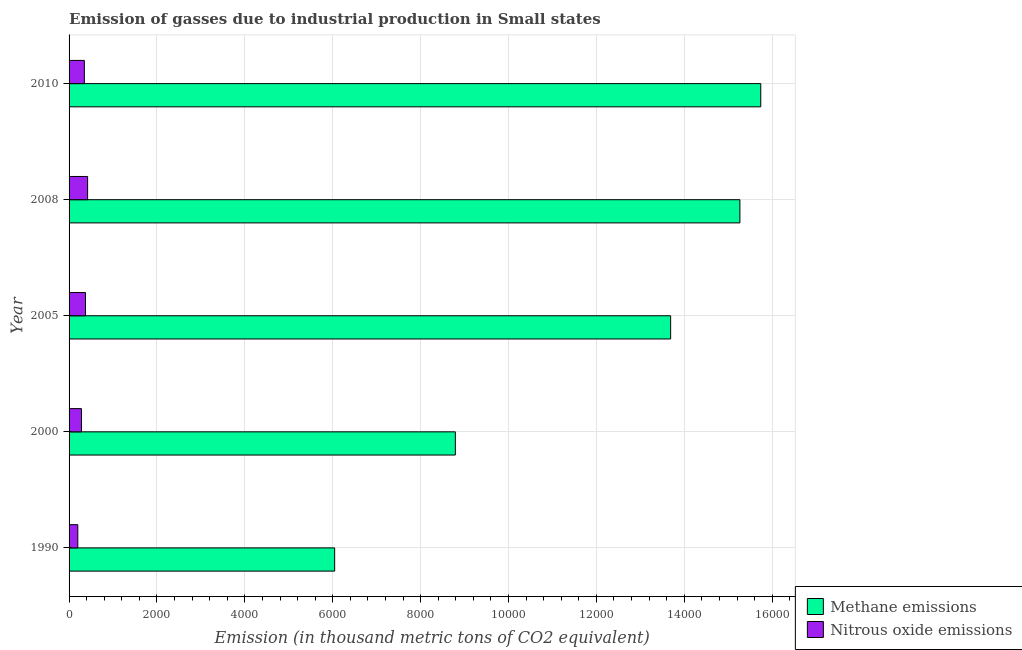How many different coloured bars are there?
Give a very brief answer. 2. Are the number of bars per tick equal to the number of legend labels?
Give a very brief answer. Yes. How many bars are there on the 3rd tick from the top?
Keep it short and to the point. 2. What is the label of the 1st group of bars from the top?
Your response must be concise. 2010. In how many cases, is the number of bars for a given year not equal to the number of legend labels?
Ensure brevity in your answer.  0. What is the amount of methane emissions in 1990?
Your response must be concise. 6043.6. Across all years, what is the maximum amount of nitrous oxide emissions?
Give a very brief answer. 421.7. Across all years, what is the minimum amount of methane emissions?
Give a very brief answer. 6043.6. What is the total amount of methane emissions in the graph?
Ensure brevity in your answer.  5.95e+04. What is the difference between the amount of nitrous oxide emissions in 1990 and that in 2005?
Provide a short and direct response. -175.5. What is the difference between the amount of nitrous oxide emissions in 2008 and the amount of methane emissions in 1990?
Ensure brevity in your answer.  -5621.9. What is the average amount of nitrous oxide emissions per year?
Provide a succinct answer. 324.94. In the year 2005, what is the difference between the amount of methane emissions and amount of nitrous oxide emissions?
Your response must be concise. 1.33e+04. What is the ratio of the amount of nitrous oxide emissions in 2005 to that in 2008?
Your response must be concise. 0.89. Is the amount of methane emissions in 2000 less than that in 2010?
Ensure brevity in your answer.  Yes. Is the difference between the amount of methane emissions in 1990 and 2010 greater than the difference between the amount of nitrous oxide emissions in 1990 and 2010?
Keep it short and to the point. No. What is the difference between the highest and the second highest amount of methane emissions?
Keep it short and to the point. 474.8. What is the difference between the highest and the lowest amount of methane emissions?
Make the answer very short. 9696.7. In how many years, is the amount of methane emissions greater than the average amount of methane emissions taken over all years?
Provide a short and direct response. 3. What does the 2nd bar from the top in 2000 represents?
Ensure brevity in your answer.  Methane emissions. What does the 2nd bar from the bottom in 2005 represents?
Give a very brief answer. Nitrous oxide emissions. How many years are there in the graph?
Make the answer very short. 5. Does the graph contain any zero values?
Your response must be concise. No. Where does the legend appear in the graph?
Provide a succinct answer. Bottom right. How many legend labels are there?
Offer a very short reply. 2. How are the legend labels stacked?
Your response must be concise. Vertical. What is the title of the graph?
Your response must be concise. Emission of gasses due to industrial production in Small states. Does "Private creditors" appear as one of the legend labels in the graph?
Give a very brief answer. No. What is the label or title of the X-axis?
Your answer should be very brief. Emission (in thousand metric tons of CO2 equivalent). What is the Emission (in thousand metric tons of CO2 equivalent) of Methane emissions in 1990?
Give a very brief answer. 6043.6. What is the Emission (in thousand metric tons of CO2 equivalent) in Nitrous oxide emissions in 1990?
Your response must be concise. 198.5. What is the Emission (in thousand metric tons of CO2 equivalent) in Methane emissions in 2000?
Give a very brief answer. 8790. What is the Emission (in thousand metric tons of CO2 equivalent) in Nitrous oxide emissions in 2000?
Provide a short and direct response. 282.6. What is the Emission (in thousand metric tons of CO2 equivalent) of Methane emissions in 2005?
Offer a terse response. 1.37e+04. What is the Emission (in thousand metric tons of CO2 equivalent) of Nitrous oxide emissions in 2005?
Your answer should be compact. 374. What is the Emission (in thousand metric tons of CO2 equivalent) in Methane emissions in 2008?
Your response must be concise. 1.53e+04. What is the Emission (in thousand metric tons of CO2 equivalent) of Nitrous oxide emissions in 2008?
Ensure brevity in your answer.  421.7. What is the Emission (in thousand metric tons of CO2 equivalent) of Methane emissions in 2010?
Give a very brief answer. 1.57e+04. What is the Emission (in thousand metric tons of CO2 equivalent) in Nitrous oxide emissions in 2010?
Keep it short and to the point. 347.9. Across all years, what is the maximum Emission (in thousand metric tons of CO2 equivalent) of Methane emissions?
Ensure brevity in your answer.  1.57e+04. Across all years, what is the maximum Emission (in thousand metric tons of CO2 equivalent) of Nitrous oxide emissions?
Offer a very short reply. 421.7. Across all years, what is the minimum Emission (in thousand metric tons of CO2 equivalent) in Methane emissions?
Ensure brevity in your answer.  6043.6. Across all years, what is the minimum Emission (in thousand metric tons of CO2 equivalent) in Nitrous oxide emissions?
Provide a short and direct response. 198.5. What is the total Emission (in thousand metric tons of CO2 equivalent) in Methane emissions in the graph?
Make the answer very short. 5.95e+04. What is the total Emission (in thousand metric tons of CO2 equivalent) in Nitrous oxide emissions in the graph?
Keep it short and to the point. 1624.7. What is the difference between the Emission (in thousand metric tons of CO2 equivalent) in Methane emissions in 1990 and that in 2000?
Ensure brevity in your answer.  -2746.4. What is the difference between the Emission (in thousand metric tons of CO2 equivalent) in Nitrous oxide emissions in 1990 and that in 2000?
Your answer should be very brief. -84.1. What is the difference between the Emission (in thousand metric tons of CO2 equivalent) of Methane emissions in 1990 and that in 2005?
Offer a very short reply. -7645.8. What is the difference between the Emission (in thousand metric tons of CO2 equivalent) in Nitrous oxide emissions in 1990 and that in 2005?
Provide a short and direct response. -175.5. What is the difference between the Emission (in thousand metric tons of CO2 equivalent) of Methane emissions in 1990 and that in 2008?
Your answer should be compact. -9221.9. What is the difference between the Emission (in thousand metric tons of CO2 equivalent) in Nitrous oxide emissions in 1990 and that in 2008?
Your response must be concise. -223.2. What is the difference between the Emission (in thousand metric tons of CO2 equivalent) in Methane emissions in 1990 and that in 2010?
Make the answer very short. -9696.7. What is the difference between the Emission (in thousand metric tons of CO2 equivalent) in Nitrous oxide emissions in 1990 and that in 2010?
Provide a succinct answer. -149.4. What is the difference between the Emission (in thousand metric tons of CO2 equivalent) of Methane emissions in 2000 and that in 2005?
Keep it short and to the point. -4899.4. What is the difference between the Emission (in thousand metric tons of CO2 equivalent) of Nitrous oxide emissions in 2000 and that in 2005?
Your response must be concise. -91.4. What is the difference between the Emission (in thousand metric tons of CO2 equivalent) in Methane emissions in 2000 and that in 2008?
Your response must be concise. -6475.5. What is the difference between the Emission (in thousand metric tons of CO2 equivalent) in Nitrous oxide emissions in 2000 and that in 2008?
Keep it short and to the point. -139.1. What is the difference between the Emission (in thousand metric tons of CO2 equivalent) of Methane emissions in 2000 and that in 2010?
Make the answer very short. -6950.3. What is the difference between the Emission (in thousand metric tons of CO2 equivalent) of Nitrous oxide emissions in 2000 and that in 2010?
Your answer should be compact. -65.3. What is the difference between the Emission (in thousand metric tons of CO2 equivalent) in Methane emissions in 2005 and that in 2008?
Keep it short and to the point. -1576.1. What is the difference between the Emission (in thousand metric tons of CO2 equivalent) in Nitrous oxide emissions in 2005 and that in 2008?
Keep it short and to the point. -47.7. What is the difference between the Emission (in thousand metric tons of CO2 equivalent) of Methane emissions in 2005 and that in 2010?
Offer a very short reply. -2050.9. What is the difference between the Emission (in thousand metric tons of CO2 equivalent) in Nitrous oxide emissions in 2005 and that in 2010?
Offer a very short reply. 26.1. What is the difference between the Emission (in thousand metric tons of CO2 equivalent) of Methane emissions in 2008 and that in 2010?
Give a very brief answer. -474.8. What is the difference between the Emission (in thousand metric tons of CO2 equivalent) of Nitrous oxide emissions in 2008 and that in 2010?
Make the answer very short. 73.8. What is the difference between the Emission (in thousand metric tons of CO2 equivalent) in Methane emissions in 1990 and the Emission (in thousand metric tons of CO2 equivalent) in Nitrous oxide emissions in 2000?
Offer a terse response. 5761. What is the difference between the Emission (in thousand metric tons of CO2 equivalent) in Methane emissions in 1990 and the Emission (in thousand metric tons of CO2 equivalent) in Nitrous oxide emissions in 2005?
Keep it short and to the point. 5669.6. What is the difference between the Emission (in thousand metric tons of CO2 equivalent) of Methane emissions in 1990 and the Emission (in thousand metric tons of CO2 equivalent) of Nitrous oxide emissions in 2008?
Your answer should be very brief. 5621.9. What is the difference between the Emission (in thousand metric tons of CO2 equivalent) of Methane emissions in 1990 and the Emission (in thousand metric tons of CO2 equivalent) of Nitrous oxide emissions in 2010?
Provide a succinct answer. 5695.7. What is the difference between the Emission (in thousand metric tons of CO2 equivalent) in Methane emissions in 2000 and the Emission (in thousand metric tons of CO2 equivalent) in Nitrous oxide emissions in 2005?
Keep it short and to the point. 8416. What is the difference between the Emission (in thousand metric tons of CO2 equivalent) in Methane emissions in 2000 and the Emission (in thousand metric tons of CO2 equivalent) in Nitrous oxide emissions in 2008?
Your answer should be compact. 8368.3. What is the difference between the Emission (in thousand metric tons of CO2 equivalent) of Methane emissions in 2000 and the Emission (in thousand metric tons of CO2 equivalent) of Nitrous oxide emissions in 2010?
Give a very brief answer. 8442.1. What is the difference between the Emission (in thousand metric tons of CO2 equivalent) in Methane emissions in 2005 and the Emission (in thousand metric tons of CO2 equivalent) in Nitrous oxide emissions in 2008?
Your response must be concise. 1.33e+04. What is the difference between the Emission (in thousand metric tons of CO2 equivalent) in Methane emissions in 2005 and the Emission (in thousand metric tons of CO2 equivalent) in Nitrous oxide emissions in 2010?
Give a very brief answer. 1.33e+04. What is the difference between the Emission (in thousand metric tons of CO2 equivalent) in Methane emissions in 2008 and the Emission (in thousand metric tons of CO2 equivalent) in Nitrous oxide emissions in 2010?
Keep it short and to the point. 1.49e+04. What is the average Emission (in thousand metric tons of CO2 equivalent) of Methane emissions per year?
Your answer should be compact. 1.19e+04. What is the average Emission (in thousand metric tons of CO2 equivalent) in Nitrous oxide emissions per year?
Your response must be concise. 324.94. In the year 1990, what is the difference between the Emission (in thousand metric tons of CO2 equivalent) in Methane emissions and Emission (in thousand metric tons of CO2 equivalent) in Nitrous oxide emissions?
Ensure brevity in your answer.  5845.1. In the year 2000, what is the difference between the Emission (in thousand metric tons of CO2 equivalent) of Methane emissions and Emission (in thousand metric tons of CO2 equivalent) of Nitrous oxide emissions?
Provide a short and direct response. 8507.4. In the year 2005, what is the difference between the Emission (in thousand metric tons of CO2 equivalent) of Methane emissions and Emission (in thousand metric tons of CO2 equivalent) of Nitrous oxide emissions?
Offer a terse response. 1.33e+04. In the year 2008, what is the difference between the Emission (in thousand metric tons of CO2 equivalent) of Methane emissions and Emission (in thousand metric tons of CO2 equivalent) of Nitrous oxide emissions?
Your response must be concise. 1.48e+04. In the year 2010, what is the difference between the Emission (in thousand metric tons of CO2 equivalent) of Methane emissions and Emission (in thousand metric tons of CO2 equivalent) of Nitrous oxide emissions?
Provide a short and direct response. 1.54e+04. What is the ratio of the Emission (in thousand metric tons of CO2 equivalent) of Methane emissions in 1990 to that in 2000?
Provide a short and direct response. 0.69. What is the ratio of the Emission (in thousand metric tons of CO2 equivalent) in Nitrous oxide emissions in 1990 to that in 2000?
Your answer should be compact. 0.7. What is the ratio of the Emission (in thousand metric tons of CO2 equivalent) in Methane emissions in 1990 to that in 2005?
Your response must be concise. 0.44. What is the ratio of the Emission (in thousand metric tons of CO2 equivalent) in Nitrous oxide emissions in 1990 to that in 2005?
Give a very brief answer. 0.53. What is the ratio of the Emission (in thousand metric tons of CO2 equivalent) of Methane emissions in 1990 to that in 2008?
Provide a short and direct response. 0.4. What is the ratio of the Emission (in thousand metric tons of CO2 equivalent) of Nitrous oxide emissions in 1990 to that in 2008?
Provide a short and direct response. 0.47. What is the ratio of the Emission (in thousand metric tons of CO2 equivalent) in Methane emissions in 1990 to that in 2010?
Your answer should be compact. 0.38. What is the ratio of the Emission (in thousand metric tons of CO2 equivalent) of Nitrous oxide emissions in 1990 to that in 2010?
Make the answer very short. 0.57. What is the ratio of the Emission (in thousand metric tons of CO2 equivalent) of Methane emissions in 2000 to that in 2005?
Provide a succinct answer. 0.64. What is the ratio of the Emission (in thousand metric tons of CO2 equivalent) in Nitrous oxide emissions in 2000 to that in 2005?
Ensure brevity in your answer.  0.76. What is the ratio of the Emission (in thousand metric tons of CO2 equivalent) in Methane emissions in 2000 to that in 2008?
Your response must be concise. 0.58. What is the ratio of the Emission (in thousand metric tons of CO2 equivalent) in Nitrous oxide emissions in 2000 to that in 2008?
Provide a short and direct response. 0.67. What is the ratio of the Emission (in thousand metric tons of CO2 equivalent) in Methane emissions in 2000 to that in 2010?
Offer a terse response. 0.56. What is the ratio of the Emission (in thousand metric tons of CO2 equivalent) of Nitrous oxide emissions in 2000 to that in 2010?
Your answer should be very brief. 0.81. What is the ratio of the Emission (in thousand metric tons of CO2 equivalent) in Methane emissions in 2005 to that in 2008?
Your answer should be very brief. 0.9. What is the ratio of the Emission (in thousand metric tons of CO2 equivalent) in Nitrous oxide emissions in 2005 to that in 2008?
Offer a very short reply. 0.89. What is the ratio of the Emission (in thousand metric tons of CO2 equivalent) in Methane emissions in 2005 to that in 2010?
Ensure brevity in your answer.  0.87. What is the ratio of the Emission (in thousand metric tons of CO2 equivalent) in Nitrous oxide emissions in 2005 to that in 2010?
Ensure brevity in your answer.  1.07. What is the ratio of the Emission (in thousand metric tons of CO2 equivalent) of Methane emissions in 2008 to that in 2010?
Give a very brief answer. 0.97. What is the ratio of the Emission (in thousand metric tons of CO2 equivalent) in Nitrous oxide emissions in 2008 to that in 2010?
Ensure brevity in your answer.  1.21. What is the difference between the highest and the second highest Emission (in thousand metric tons of CO2 equivalent) in Methane emissions?
Provide a short and direct response. 474.8. What is the difference between the highest and the second highest Emission (in thousand metric tons of CO2 equivalent) of Nitrous oxide emissions?
Ensure brevity in your answer.  47.7. What is the difference between the highest and the lowest Emission (in thousand metric tons of CO2 equivalent) in Methane emissions?
Your response must be concise. 9696.7. What is the difference between the highest and the lowest Emission (in thousand metric tons of CO2 equivalent) of Nitrous oxide emissions?
Ensure brevity in your answer.  223.2. 